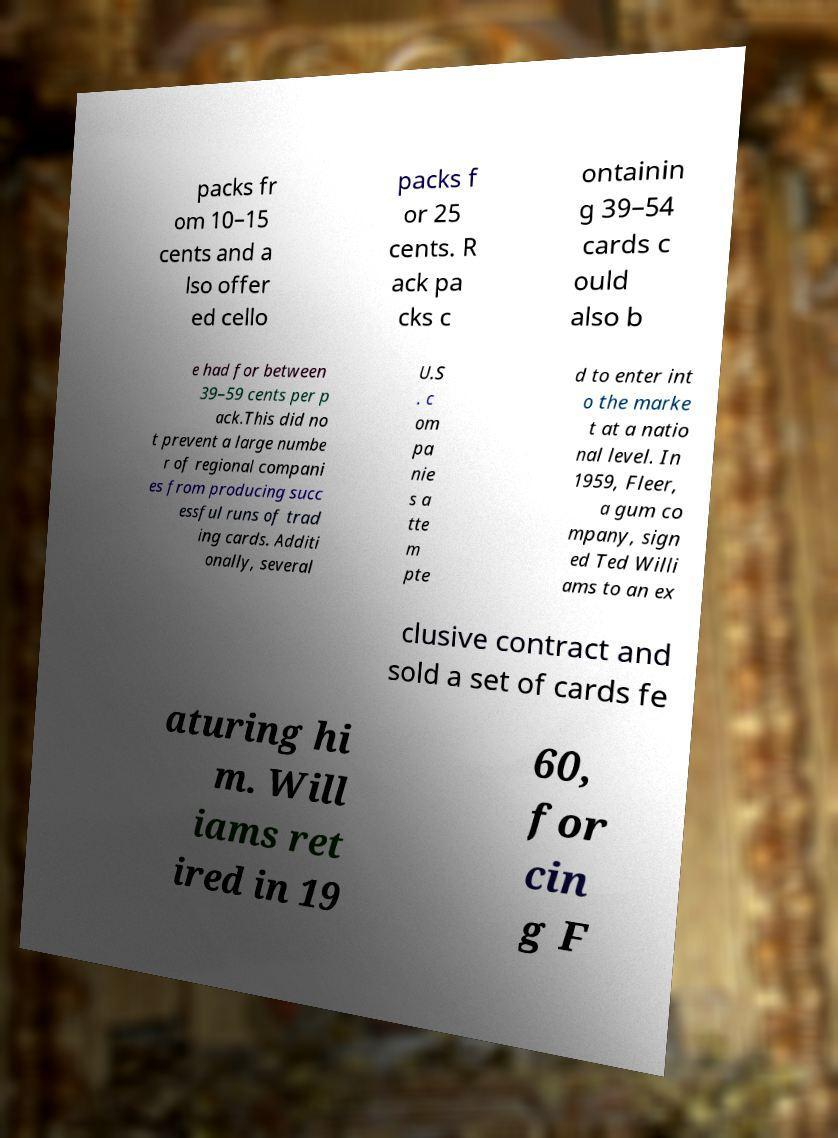For documentation purposes, I need the text within this image transcribed. Could you provide that? packs fr om 10–15 cents and a lso offer ed cello packs f or 25 cents. R ack pa cks c ontainin g 39–54 cards c ould also b e had for between 39–59 cents per p ack.This did no t prevent a large numbe r of regional compani es from producing succ essful runs of trad ing cards. Additi onally, several U.S . c om pa nie s a tte m pte d to enter int o the marke t at a natio nal level. In 1959, Fleer, a gum co mpany, sign ed Ted Willi ams to an ex clusive contract and sold a set of cards fe aturing hi m. Will iams ret ired in 19 60, for cin g F 